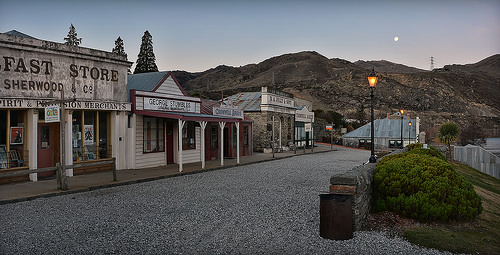<image>
Can you confirm if the moon is in front of the tower? No. The moon is not in front of the tower. The spatial positioning shows a different relationship between these objects. 